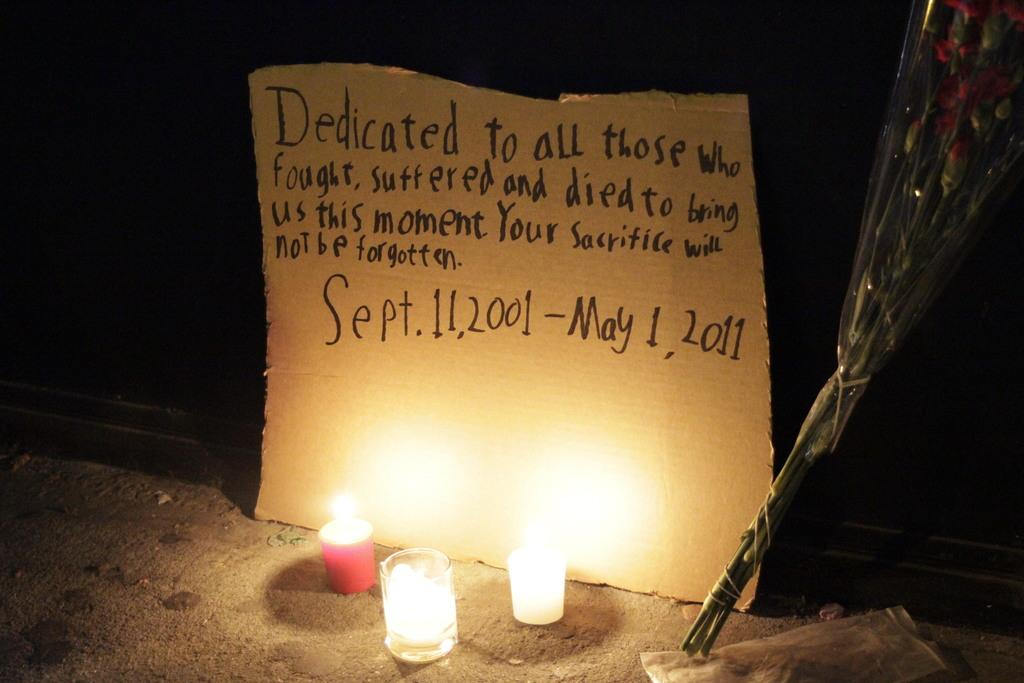What objects can be seen in the image related to lighting? There are candles in the image. What type of decorative item is present in the image? There is a bouquet in the image. What can be seen in the background of the image? There is a cardboard sheet in the background of the image. Is there any text or message on the cardboard sheet? Yes, there is writing on the cardboard sheet. What type of yoke is being used to carry the candles in the image? There is no yoke present in the image; the candles are not being carried. 